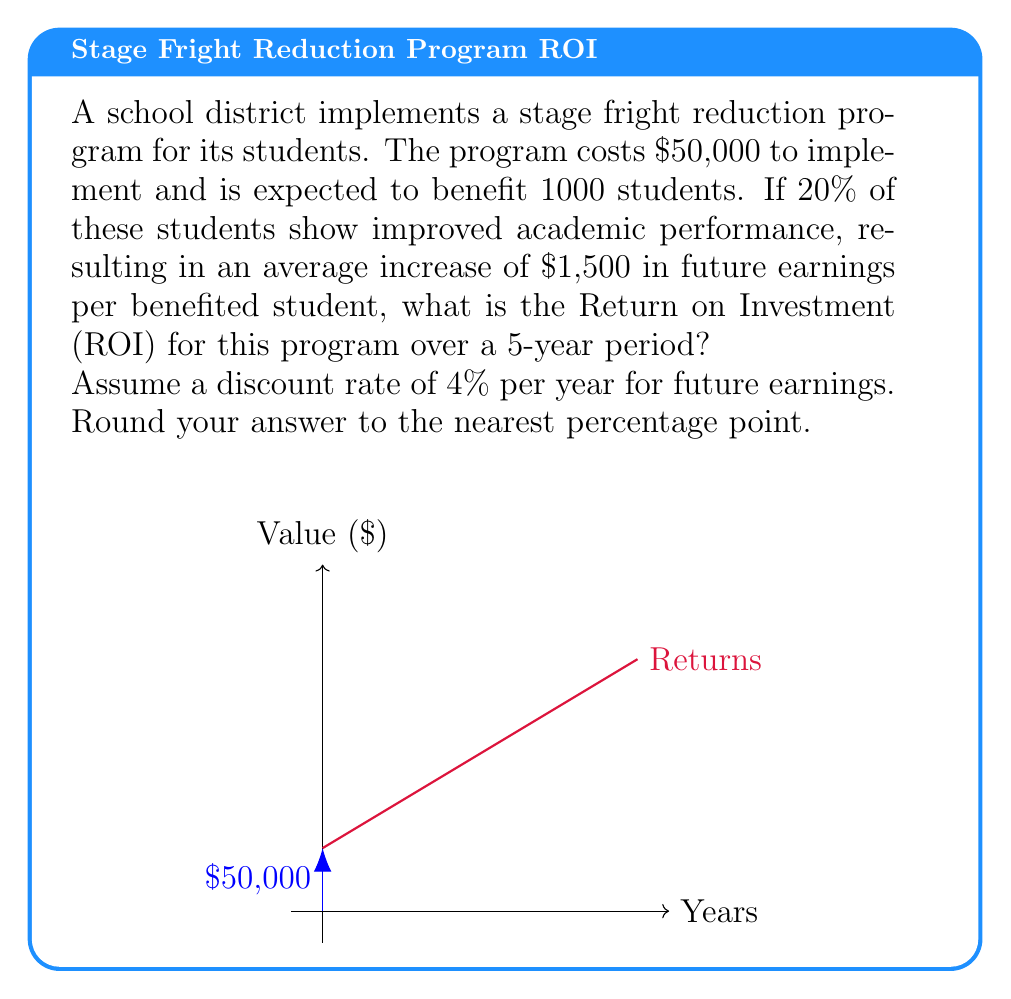Give your solution to this math problem. Let's break this down step-by-step:

1) First, calculate the number of students who benefit:
   $1000 \times 20\% = 200$ students

2) Calculate the total increase in future earnings:
   $200 \times \$1,500 = \$300,000$

3) We need to calculate the present value of this $300,000 over 5 years with a 4% discount rate. The present value formula is:

   $PV = \frac{FV}{(1+r)^n}$

   Where FV is future value, r is the discount rate, and n is the number of years.

4) Assuming the earnings increase is realized equally over 5 years:
   $\$300,000 \div 5 = \$60,000$ per year

5) Calculate the present value for each year:

   Year 1: $PV_1 = \frac{60000}{(1+0.04)^1} = 57692.31$
   Year 2: $PV_2 = \frac{60000}{(1+0.04)^2} = 55473.37$
   Year 3: $PV_3 = \frac{60000}{(1+0.04)^3} = 53339.78$
   Year 4: $PV_4 = \frac{60000}{(1+0.04)^4} = 51288.25$
   Year 5: $PV_5 = \frac{60000}{(1+0.04)^5} = 49315.62$

6) Sum up the present values:
   $\sum PV = 57692.31 + 55473.37 + 53339.78 + 51288.25 + 49315.62 = 267109.33$

7) Calculate ROI:
   $ROI = \frac{\text{Gain from Investment} - \text{Cost of Investment}}{\text{Cost of Investment}} \times 100\%$

   $ROI = \frac{267109.33 - 50000}{50000} \times 100\% = 434.22\%$

8) Rounding to the nearest percentage point:
   $ROI \approx 434\%$
Answer: 434% 